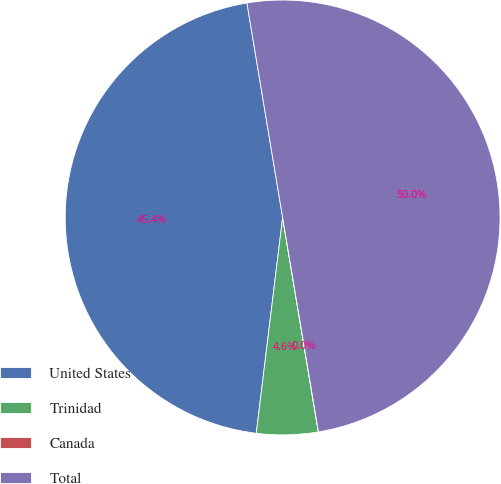<chart> <loc_0><loc_0><loc_500><loc_500><pie_chart><fcel>United States<fcel>Trinidad<fcel>Canada<fcel>Total<nl><fcel>45.44%<fcel>4.56%<fcel>0.01%<fcel>49.99%<nl></chart> 